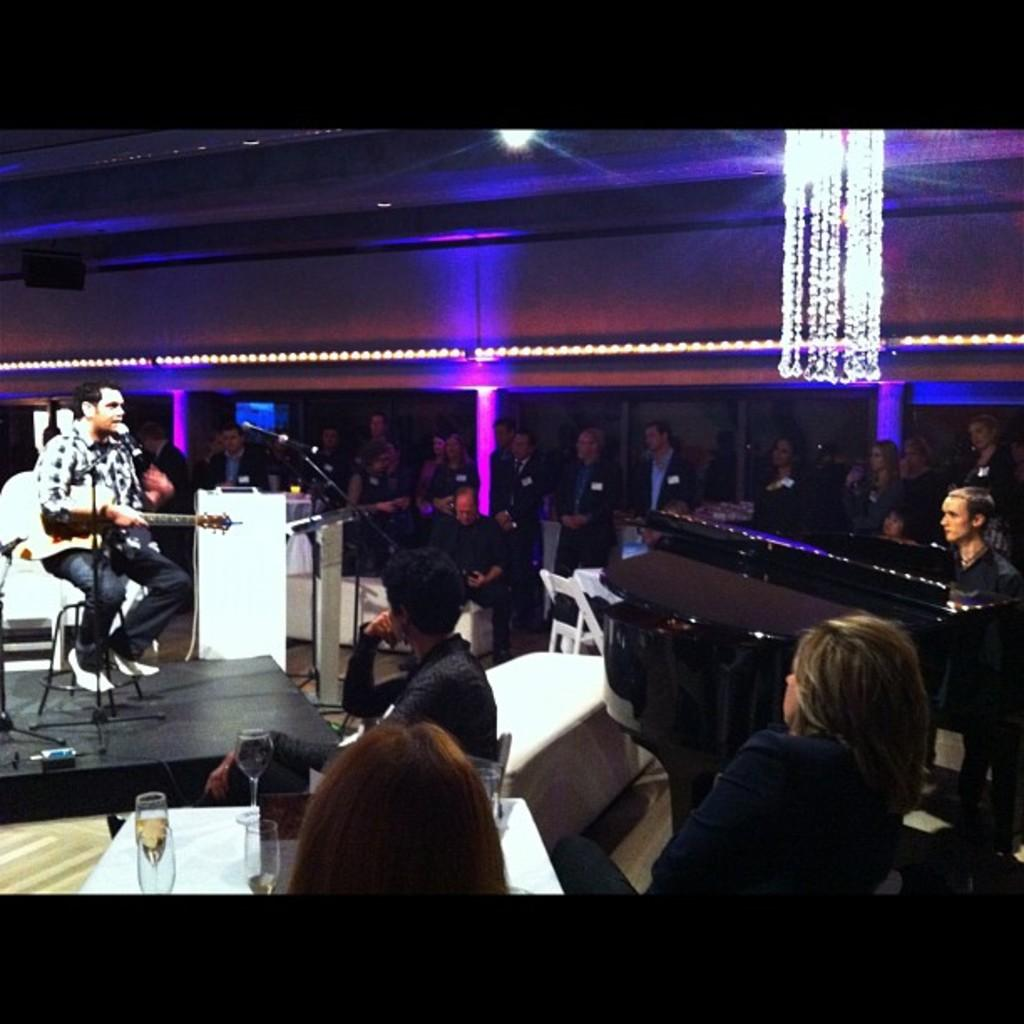What is the man in the image doing? The man is sitting on a chair and playing the guitar. Are there any other people in the image? Yes, there are people observing the scene in the image. What can be seen at the top of the image? There are lights visible at the top of the image. What type of yarn is the man using to play the guitar in the image? The man is not using yarn to play the guitar in the image; he is using his hands and fingers to strum the strings. 